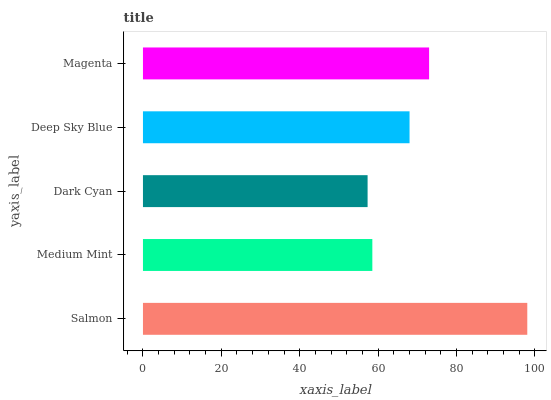Is Dark Cyan the minimum?
Answer yes or no. Yes. Is Salmon the maximum?
Answer yes or no. Yes. Is Medium Mint the minimum?
Answer yes or no. No. Is Medium Mint the maximum?
Answer yes or no. No. Is Salmon greater than Medium Mint?
Answer yes or no. Yes. Is Medium Mint less than Salmon?
Answer yes or no. Yes. Is Medium Mint greater than Salmon?
Answer yes or no. No. Is Salmon less than Medium Mint?
Answer yes or no. No. Is Deep Sky Blue the high median?
Answer yes or no. Yes. Is Deep Sky Blue the low median?
Answer yes or no. Yes. Is Magenta the high median?
Answer yes or no. No. Is Medium Mint the low median?
Answer yes or no. No. 